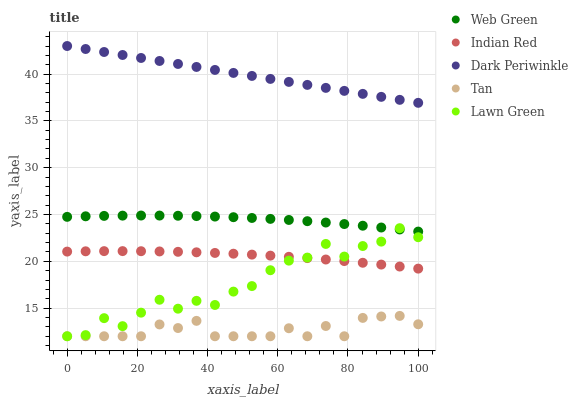Does Tan have the minimum area under the curve?
Answer yes or no. Yes. Does Dark Periwinkle have the maximum area under the curve?
Answer yes or no. Yes. Does Indian Red have the minimum area under the curve?
Answer yes or no. No. Does Indian Red have the maximum area under the curve?
Answer yes or no. No. Is Dark Periwinkle the smoothest?
Answer yes or no. Yes. Is Lawn Green the roughest?
Answer yes or no. Yes. Is Tan the smoothest?
Answer yes or no. No. Is Tan the roughest?
Answer yes or no. No. Does Lawn Green have the lowest value?
Answer yes or no. Yes. Does Indian Red have the lowest value?
Answer yes or no. No. Does Dark Periwinkle have the highest value?
Answer yes or no. Yes. Does Indian Red have the highest value?
Answer yes or no. No. Is Tan less than Indian Red?
Answer yes or no. Yes. Is Dark Periwinkle greater than Lawn Green?
Answer yes or no. Yes. Does Indian Red intersect Lawn Green?
Answer yes or no. Yes. Is Indian Red less than Lawn Green?
Answer yes or no. No. Is Indian Red greater than Lawn Green?
Answer yes or no. No. Does Tan intersect Indian Red?
Answer yes or no. No. 